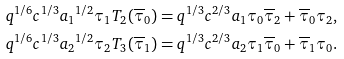<formula> <loc_0><loc_0><loc_500><loc_500>& q ^ { 1 / 6 } c ^ { 1 / 3 } { a _ { 1 } } ^ { 1 / 2 } \tau _ { 1 } T _ { 2 } ( \overline { \tau } _ { 0 } ) = q ^ { 1 / 3 } c ^ { 2 / 3 } a _ { 1 } \tau _ { 0 } \overline { \tau } _ { 2 } + \overline { \tau } _ { 0 } \tau _ { 2 } , \\ & q ^ { 1 / 6 } c ^ { 1 / 3 } { a _ { 2 } } ^ { 1 / 2 } \tau _ { 2 } T _ { 3 } ( \overline { \tau } _ { 1 } ) = q ^ { 1 / 3 } c ^ { 2 / 3 } a _ { 2 } \tau _ { 1 } \overline { \tau } _ { 0 } + \overline { \tau } _ { 1 } \tau _ { 0 } .</formula> 